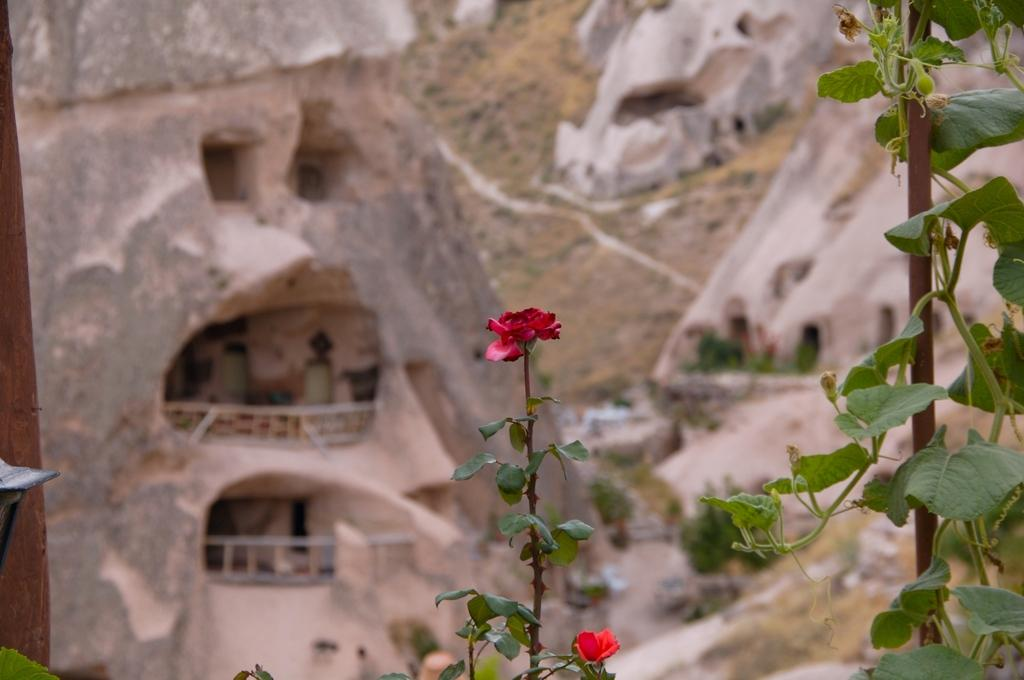What type of plants can be seen in the image? There are plants with flowers in the image. What can be seen in the background of the image? There appears to be a building in the background of the image. What other natural elements are present in the image? There are rocks and trees in the image. What type of pleasure can be seen enjoying the cherry in the image? There is no pleasure or cherry present in the image; it features plants with flowers, a building in the background, rocks, and trees. What class of students is attending the lecture in the image? There is no class or lecture present in the image. 